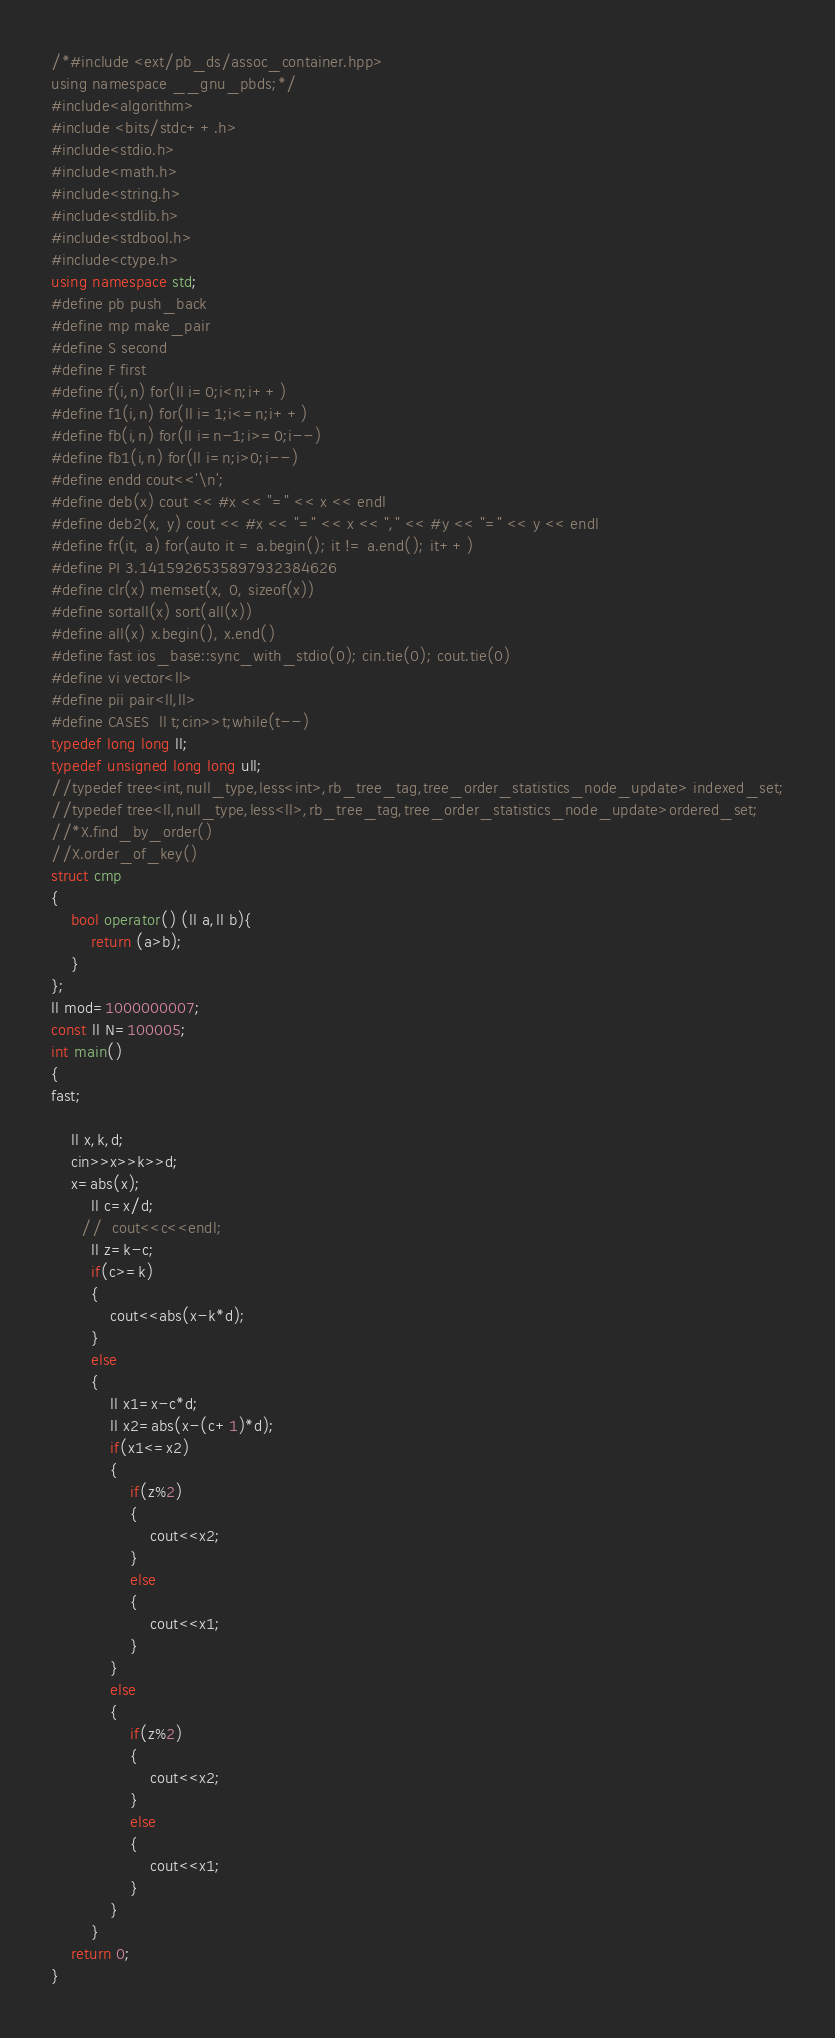<code> <loc_0><loc_0><loc_500><loc_500><_C++_>/*#include <ext/pb_ds/assoc_container.hpp>
using namespace __gnu_pbds;*/
#include<algorithm>
#include <bits/stdc++.h>
#include<stdio.h>
#include<math.h>
#include<string.h>
#include<stdlib.h>
#include<stdbool.h>
#include<ctype.h>
using namespace std;
#define pb push_back
#define mp make_pair
#define S second
#define F first
#define f(i,n) for(ll i=0;i<n;i++)
#define f1(i,n) for(ll i=1;i<=n;i++)
#define fb(i,n) for(ll i=n-1;i>=0;i--)
#define fb1(i,n) for(ll i=n;i>0;i--)
#define endd cout<<'\n';
#define deb(x) cout << #x << "=" << x << endl
#define deb2(x, y) cout << #x << "=" << x << "," << #y << "=" << y << endl
#define fr(it, a) for(auto it = a.begin(); it != a.end(); it++)
#define PI 3.1415926535897932384626
#define clr(x) memset(x, 0, sizeof(x))
#define sortall(x) sort(all(x))
#define all(x) x.begin(), x.end()
#define fast ios_base::sync_with_stdio(0); cin.tie(0); cout.tie(0)
#define vi vector<ll>
#define pii pair<ll,ll>
#define CASES  ll t;cin>>t;while(t--)
typedef long long ll;
typedef unsigned long long ull;
//typedef tree<int,null_type,less<int>,rb_tree_tag,tree_order_statistics_node_update> indexed_set;
//typedef tree<ll,null_type,less<ll>,rb_tree_tag,tree_order_statistics_node_update>ordered_set;
//*X.find_by_order()
//X.order_of_key()
struct cmp
{
	bool operator() (ll a,ll b){
		return (a>b);
	}
};
ll mod=1000000007;
const ll N=100005;
int main()
{
fast;
    
    ll x,k,d;
    cin>>x>>k>>d;
    x=abs(x); 
        ll c=x/d;
      //  cout<<c<<endl;
        ll z=k-c;
        if(c>=k)
        {
            cout<<abs(x-k*d);
        }
        else
        {
            ll x1=x-c*d;
            ll x2=abs(x-(c+1)*d);
            if(x1<=x2)
            {
                if(z%2)
                {
                    cout<<x2;
                }
                else
                {
                    cout<<x1;
                }
            }
            else
            {
                if(z%2)
                {
                    cout<<x2;
                }
                else
                {
                    cout<<x1;
                }
            }
        }
    return 0;
}
</code> 